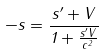<formula> <loc_0><loc_0><loc_500><loc_500>- s = \frac { s ^ { \prime } + V } { 1 + \frac { s ^ { \prime } V } { c ^ { 2 } } }</formula> 